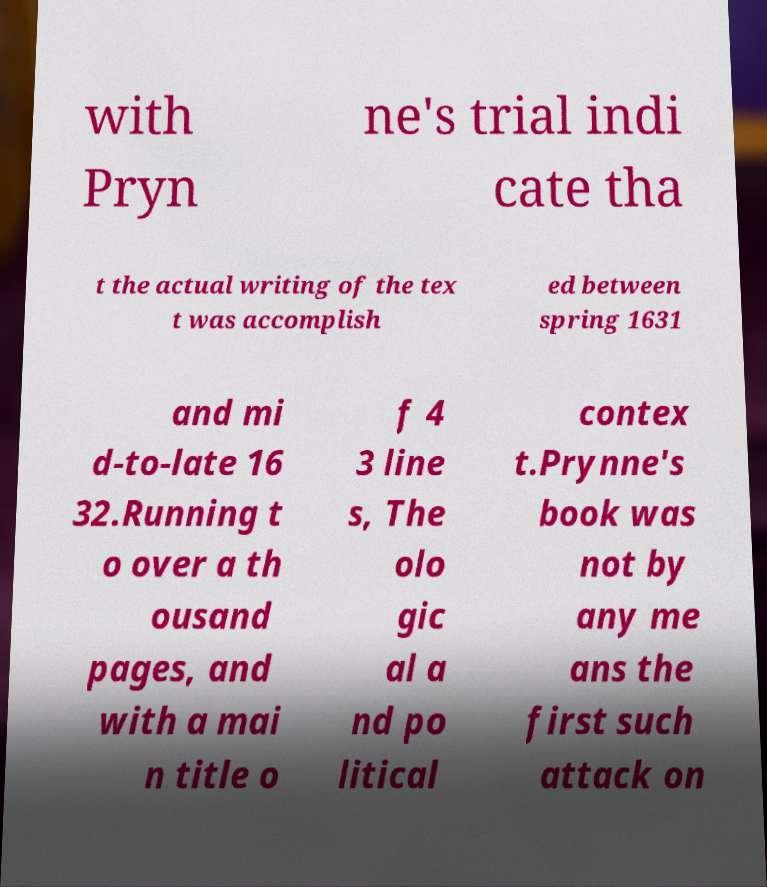Can you accurately transcribe the text from the provided image for me? with Pryn ne's trial indi cate tha t the actual writing of the tex t was accomplish ed between spring 1631 and mi d-to-late 16 32.Running t o over a th ousand pages, and with a mai n title o f 4 3 line s, The olo gic al a nd po litical contex t.Prynne's book was not by any me ans the first such attack on 